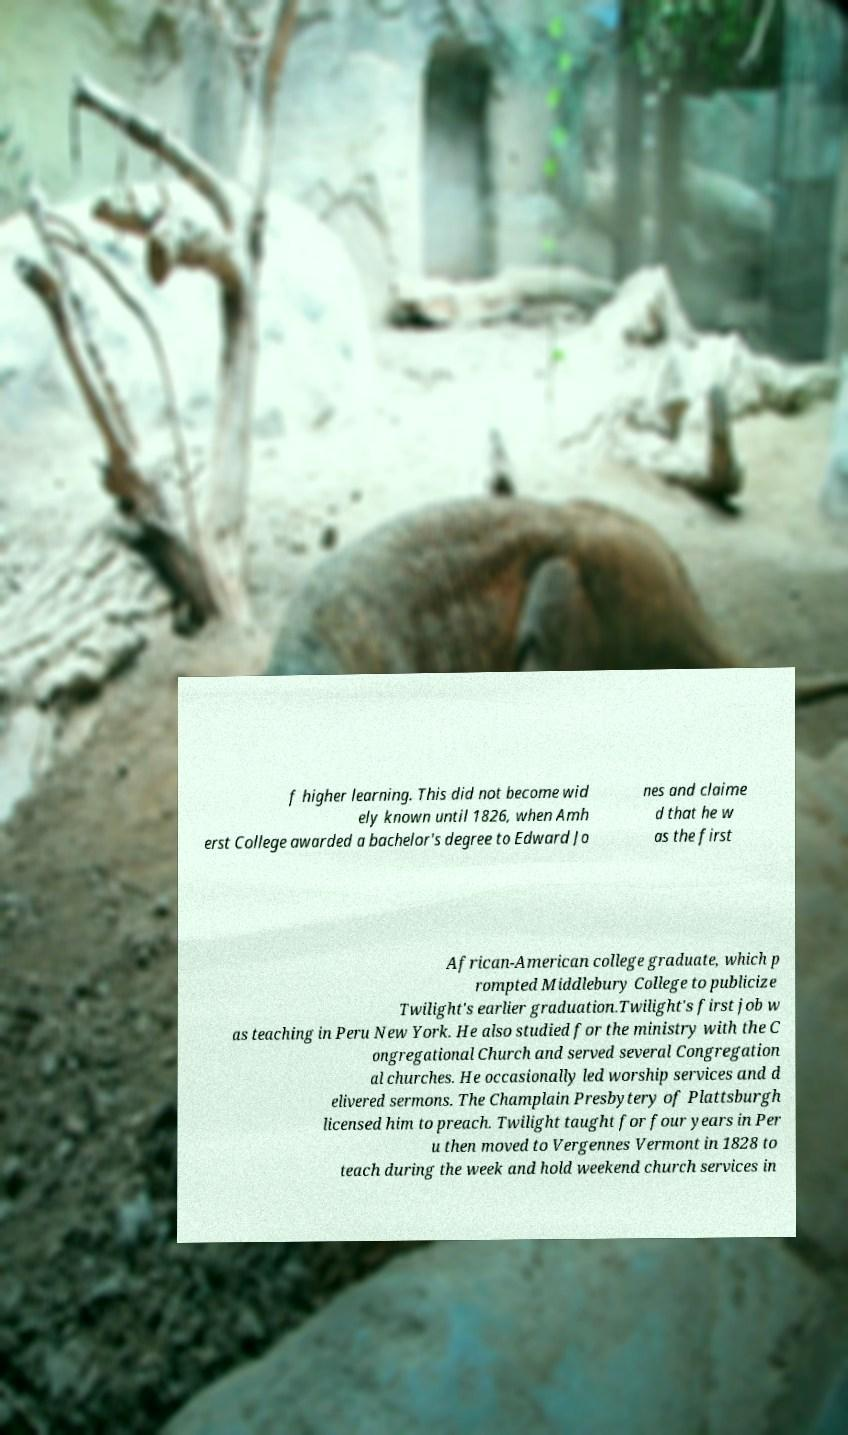What messages or text are displayed in this image? I need them in a readable, typed format. f higher learning. This did not become wid ely known until 1826, when Amh erst College awarded a bachelor's degree to Edward Jo nes and claime d that he w as the first African-American college graduate, which p rompted Middlebury College to publicize Twilight's earlier graduation.Twilight's first job w as teaching in Peru New York. He also studied for the ministry with the C ongregational Church and served several Congregation al churches. He occasionally led worship services and d elivered sermons. The Champlain Presbytery of Plattsburgh licensed him to preach. Twilight taught for four years in Per u then moved to Vergennes Vermont in 1828 to teach during the week and hold weekend church services in 